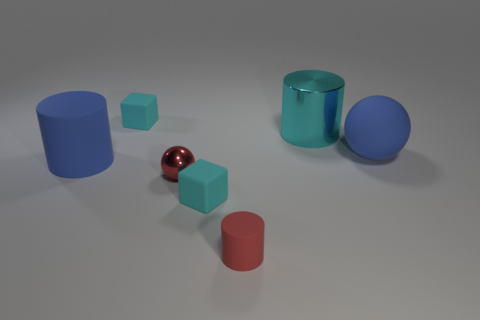Can you infer anything about the texture of the surfaces upon which these objects are placed? The surface upon which the objects rest seems to have a slight texture, as indicated by the subtle, uneven reflections and shadows beneath the objects. This suggests it's not perfectly smooth and may have a fine, grainy texture which is not overly reflective, allowing for the objects to stand out. 